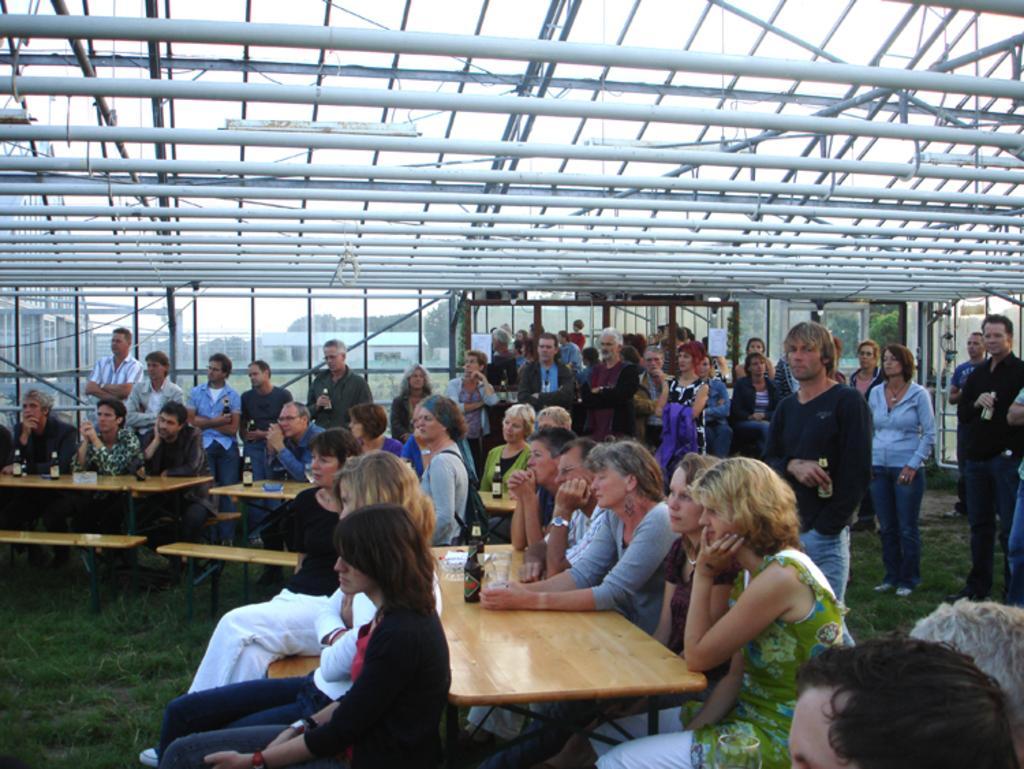How would you summarize this image in a sentence or two? In this image i can see a group of people sitting on benches and few people standing behind them. In the background i can see a glass windows through which i can see buildings, sky and some trees. 